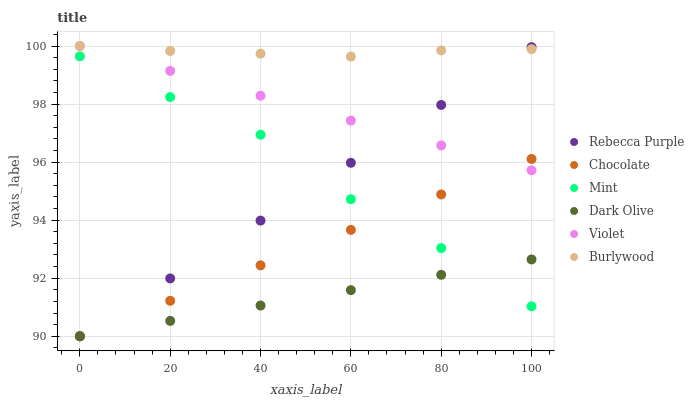Does Dark Olive have the minimum area under the curve?
Answer yes or no. Yes. Does Burlywood have the maximum area under the curve?
Answer yes or no. Yes. Does Chocolate have the minimum area under the curve?
Answer yes or no. No. Does Chocolate have the maximum area under the curve?
Answer yes or no. No. Is Rebecca Purple the smoothest?
Answer yes or no. Yes. Is Mint the roughest?
Answer yes or no. Yes. Is Dark Olive the smoothest?
Answer yes or no. No. Is Dark Olive the roughest?
Answer yes or no. No. Does Dark Olive have the lowest value?
Answer yes or no. Yes. Does Violet have the lowest value?
Answer yes or no. No. Does Violet have the highest value?
Answer yes or no. Yes. Does Chocolate have the highest value?
Answer yes or no. No. Is Mint less than Burlywood?
Answer yes or no. Yes. Is Burlywood greater than Dark Olive?
Answer yes or no. Yes. Does Mint intersect Dark Olive?
Answer yes or no. Yes. Is Mint less than Dark Olive?
Answer yes or no. No. Is Mint greater than Dark Olive?
Answer yes or no. No. Does Mint intersect Burlywood?
Answer yes or no. No. 